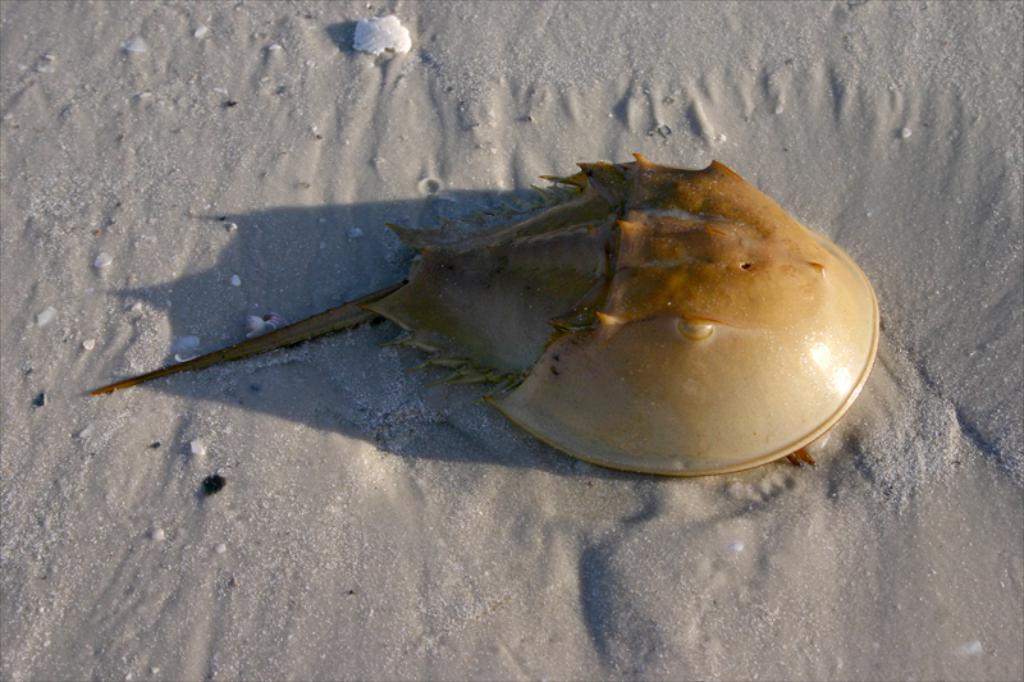What is the focus of the image? The image is zoomed in, and the focus is on an object that appears to be a skate fish in the center of the image. What can be seen on the ground in the image? There is mud visible on the ground in the image. What type of government is depicted in the image? There is no government depicted in the image; it features a skate fish and mud on the ground. How many apples are visible in the image? There are no apples present in the image. 